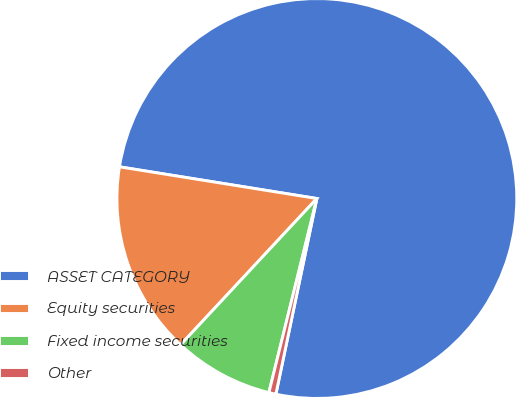Convert chart. <chart><loc_0><loc_0><loc_500><loc_500><pie_chart><fcel>ASSET CATEGORY<fcel>Equity securities<fcel>Fixed income securities<fcel>Other<nl><fcel>75.75%<fcel>15.6%<fcel>8.08%<fcel>0.57%<nl></chart> 